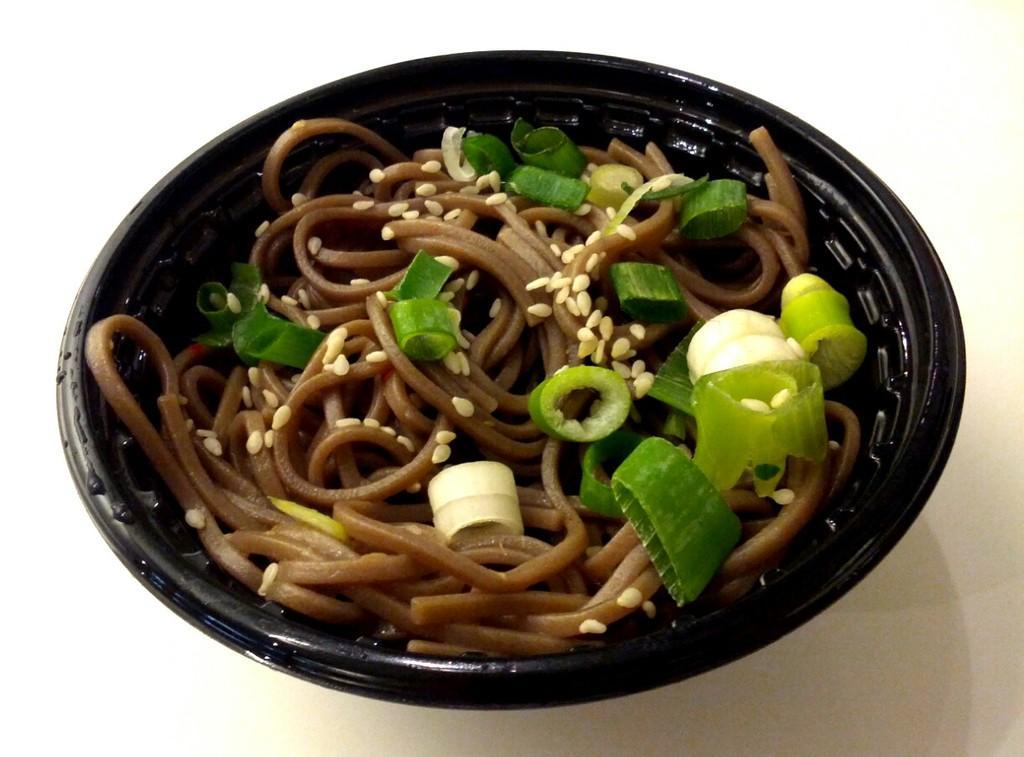In one or two sentences, can you explain what this image depicts? Here we can see food in a bowl which is on a white platform. 